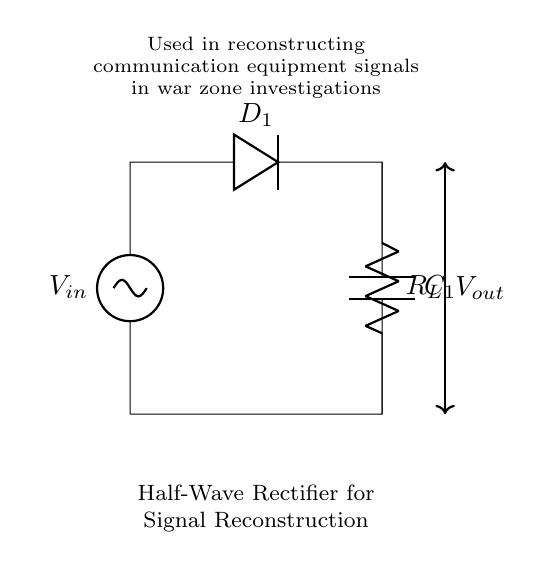What is the type of rectifier shown in the circuit? The circuit is a half-wave rectifier, characterized by the presence of a single diode that allows current to flow in one direction, effectively blocking the negative half of the input AC signal.
Answer: half-wave rectifier What component is used to smooth the output voltage in the circuit? A capacitor labeled C1 is used for smoothing the output voltage by charging during the peaks of the rectified signal and discharging during the valleys, thus providing a more stable output voltage.
Answer: C1 What happens to the current during the negative half-cycle of the input signal? During the negative half-cycle, the diode D1 becomes reverse-biased and does not conduct, resulting in zero current flowing through the load resistor R_L.
Answer: Zero current What is the purpose of the load resistor in the circuit? The load resistor R_L serves as the component that consumes the power from the rectified voltage, allowing for a usable output signal that can be used in communication equipment.
Answer: R_L How many diodes are present in the circuit? There is one diode, labeled D1, present in the half-wave rectifier circuit, which is responsible for allowing current flow only in one direction.
Answer: One diode What does the output voltage represent in the circuit? The output voltage, labeled V_out, represents the voltage across the load resistor R_L, which is the rectified and smoothed version of the input AC voltage supplied to V_in.
Answer: V_out 